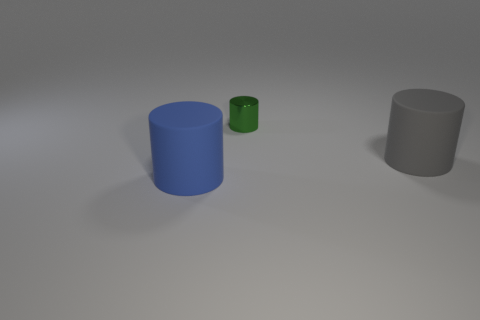Add 3 big matte things. How many objects exist? 6 Subtract all gray cylinders. How many cylinders are left? 2 Subtract all blue matte cylinders. How many cylinders are left? 2 Subtract all blue blocks. How many blue cylinders are left? 1 Add 2 green cylinders. How many green cylinders exist? 3 Subtract 0 gray spheres. How many objects are left? 3 Subtract 3 cylinders. How many cylinders are left? 0 Subtract all cyan cylinders. Subtract all yellow spheres. How many cylinders are left? 3 Subtract all big matte blocks. Subtract all blue things. How many objects are left? 2 Add 1 gray matte cylinders. How many gray matte cylinders are left? 2 